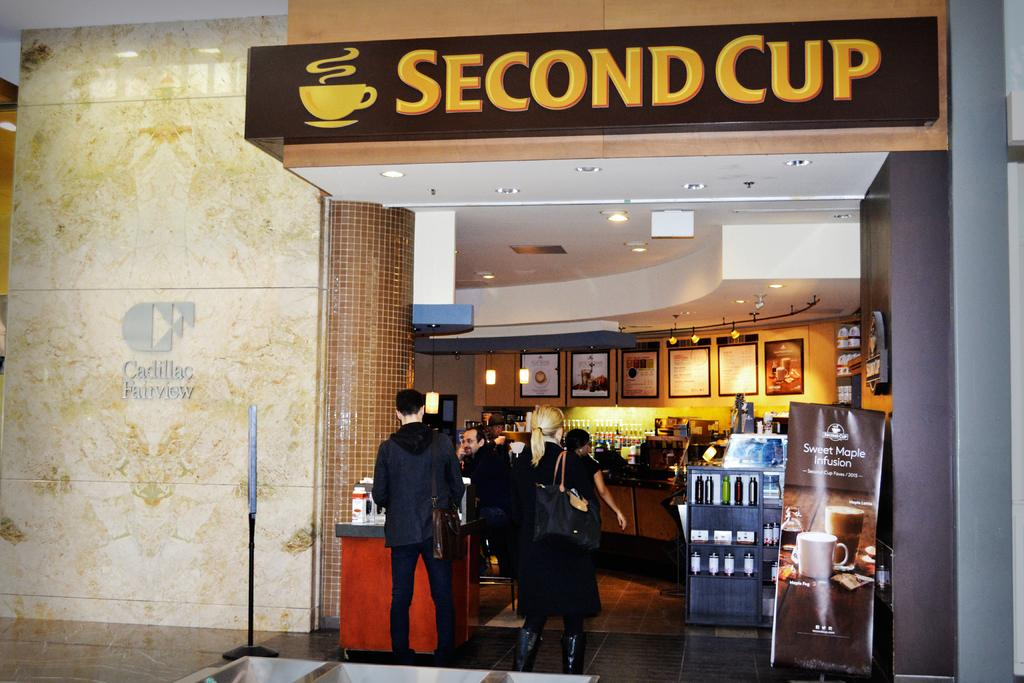Provide a one-sentence caption for the provided image. People enter a busy coffee shop named second cup. 